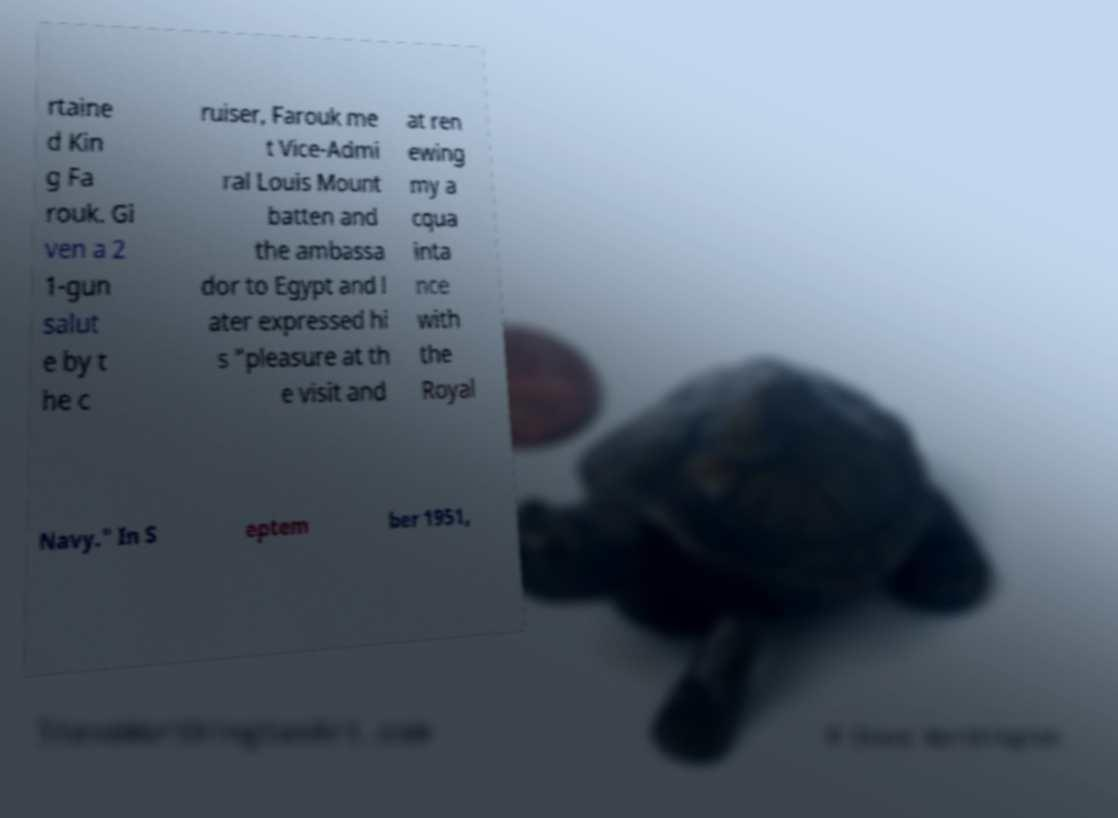Please read and relay the text visible in this image. What does it say? rtaine d Kin g Fa rouk. Gi ven a 2 1-gun salut e by t he c ruiser, Farouk me t Vice-Admi ral Louis Mount batten and the ambassa dor to Egypt and l ater expressed hi s "pleasure at th e visit and at ren ewing my a cqua inta nce with the Royal Navy." In S eptem ber 1951, 